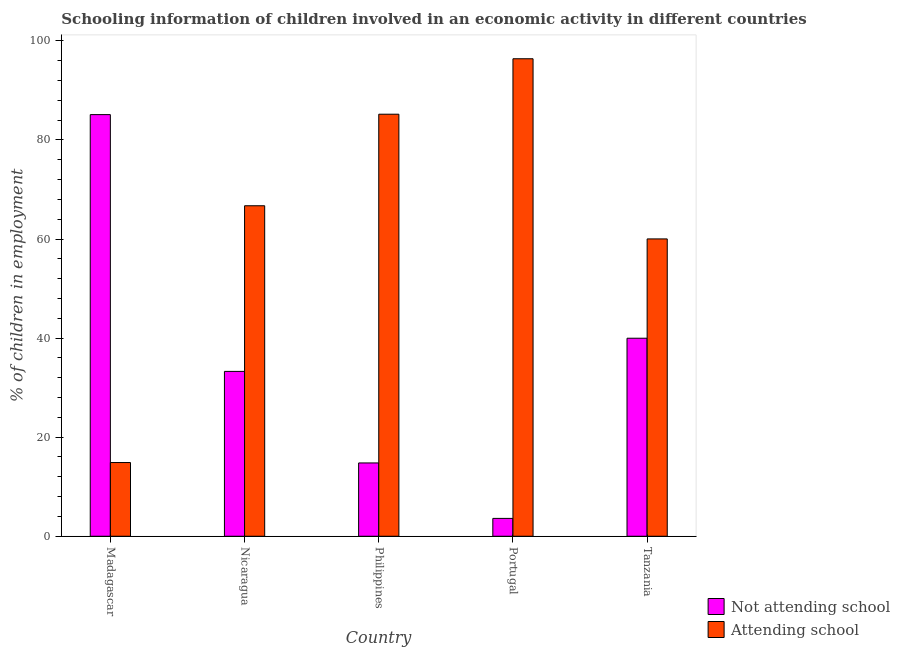How many groups of bars are there?
Your answer should be compact. 5. What is the label of the 3rd group of bars from the left?
Give a very brief answer. Philippines. What is the percentage of employed children who are attending school in Nicaragua?
Ensure brevity in your answer.  66.72. Across all countries, what is the maximum percentage of employed children who are not attending school?
Make the answer very short. 85.12. Across all countries, what is the minimum percentage of employed children who are attending school?
Your answer should be very brief. 14.88. In which country was the percentage of employed children who are not attending school maximum?
Your answer should be very brief. Madagascar. In which country was the percentage of employed children who are attending school minimum?
Provide a short and direct response. Madagascar. What is the total percentage of employed children who are attending school in the graph?
Your answer should be compact. 323.22. What is the difference between the percentage of employed children who are not attending school in Nicaragua and that in Philippines?
Keep it short and to the point. 18.48. What is the difference between the percentage of employed children who are not attending school in Philippines and the percentage of employed children who are attending school in Tanzania?
Provide a short and direct response. -45.23. What is the average percentage of employed children who are attending school per country?
Offer a very short reply. 64.64. What is the difference between the percentage of employed children who are attending school and percentage of employed children who are not attending school in Nicaragua?
Your answer should be very brief. 33.44. What is the ratio of the percentage of employed children who are not attending school in Madagascar to that in Tanzania?
Give a very brief answer. 2.13. Is the percentage of employed children who are not attending school in Madagascar less than that in Portugal?
Offer a very short reply. No. What is the difference between the highest and the second highest percentage of employed children who are not attending school?
Your answer should be compact. 45.14. What is the difference between the highest and the lowest percentage of employed children who are not attending school?
Provide a short and direct response. 81.51. In how many countries, is the percentage of employed children who are not attending school greater than the average percentage of employed children who are not attending school taken over all countries?
Give a very brief answer. 2. What does the 1st bar from the left in Nicaragua represents?
Offer a terse response. Not attending school. What does the 2nd bar from the right in Nicaragua represents?
Provide a succinct answer. Not attending school. Are all the bars in the graph horizontal?
Give a very brief answer. No. What is the difference between two consecutive major ticks on the Y-axis?
Offer a very short reply. 20. Does the graph contain any zero values?
Make the answer very short. No. How are the legend labels stacked?
Your response must be concise. Vertical. What is the title of the graph?
Offer a very short reply. Schooling information of children involved in an economic activity in different countries. Does "Excluding technical cooperation" appear as one of the legend labels in the graph?
Give a very brief answer. No. What is the label or title of the Y-axis?
Keep it short and to the point. % of children in employment. What is the % of children in employment in Not attending school in Madagascar?
Ensure brevity in your answer.  85.12. What is the % of children in employment of Attending school in Madagascar?
Give a very brief answer. 14.88. What is the % of children in employment of Not attending school in Nicaragua?
Your answer should be very brief. 33.28. What is the % of children in employment in Attending school in Nicaragua?
Keep it short and to the point. 66.72. What is the % of children in employment in Not attending school in Philippines?
Offer a terse response. 14.8. What is the % of children in employment in Attending school in Philippines?
Provide a short and direct response. 85.2. What is the % of children in employment of Not attending school in Portugal?
Make the answer very short. 3.6. What is the % of children in employment of Attending school in Portugal?
Ensure brevity in your answer.  96.4. What is the % of children in employment in Not attending school in Tanzania?
Make the answer very short. 39.98. What is the % of children in employment in Attending school in Tanzania?
Your response must be concise. 60.02. Across all countries, what is the maximum % of children in employment in Not attending school?
Make the answer very short. 85.12. Across all countries, what is the maximum % of children in employment of Attending school?
Your answer should be compact. 96.4. Across all countries, what is the minimum % of children in employment of Not attending school?
Ensure brevity in your answer.  3.6. Across all countries, what is the minimum % of children in employment in Attending school?
Ensure brevity in your answer.  14.88. What is the total % of children in employment in Not attending school in the graph?
Offer a very short reply. 176.78. What is the total % of children in employment in Attending school in the graph?
Ensure brevity in your answer.  323.22. What is the difference between the % of children in employment in Not attending school in Madagascar and that in Nicaragua?
Ensure brevity in your answer.  51.84. What is the difference between the % of children in employment in Attending school in Madagascar and that in Nicaragua?
Give a very brief answer. -51.84. What is the difference between the % of children in employment in Not attending school in Madagascar and that in Philippines?
Ensure brevity in your answer.  70.32. What is the difference between the % of children in employment of Attending school in Madagascar and that in Philippines?
Make the answer very short. -70.32. What is the difference between the % of children in employment of Not attending school in Madagascar and that in Portugal?
Offer a terse response. 81.51. What is the difference between the % of children in employment in Attending school in Madagascar and that in Portugal?
Keep it short and to the point. -81.51. What is the difference between the % of children in employment of Not attending school in Madagascar and that in Tanzania?
Your response must be concise. 45.14. What is the difference between the % of children in employment in Attending school in Madagascar and that in Tanzania?
Offer a terse response. -45.14. What is the difference between the % of children in employment of Not attending school in Nicaragua and that in Philippines?
Provide a succinct answer. 18.48. What is the difference between the % of children in employment in Attending school in Nicaragua and that in Philippines?
Make the answer very short. -18.48. What is the difference between the % of children in employment in Not attending school in Nicaragua and that in Portugal?
Your answer should be compact. 29.68. What is the difference between the % of children in employment of Attending school in Nicaragua and that in Portugal?
Provide a succinct answer. -29.68. What is the difference between the % of children in employment of Not attending school in Nicaragua and that in Tanzania?
Make the answer very short. -6.69. What is the difference between the % of children in employment of Attending school in Nicaragua and that in Tanzania?
Make the answer very short. 6.69. What is the difference between the % of children in employment of Not attending school in Philippines and that in Portugal?
Give a very brief answer. 11.19. What is the difference between the % of children in employment of Attending school in Philippines and that in Portugal?
Keep it short and to the point. -11.19. What is the difference between the % of children in employment of Not attending school in Philippines and that in Tanzania?
Ensure brevity in your answer.  -25.18. What is the difference between the % of children in employment in Attending school in Philippines and that in Tanzania?
Your response must be concise. 25.18. What is the difference between the % of children in employment of Not attending school in Portugal and that in Tanzania?
Provide a short and direct response. -36.37. What is the difference between the % of children in employment of Attending school in Portugal and that in Tanzania?
Offer a terse response. 36.37. What is the difference between the % of children in employment of Not attending school in Madagascar and the % of children in employment of Attending school in Nicaragua?
Provide a short and direct response. 18.4. What is the difference between the % of children in employment in Not attending school in Madagascar and the % of children in employment in Attending school in Philippines?
Your response must be concise. -0.08. What is the difference between the % of children in employment in Not attending school in Madagascar and the % of children in employment in Attending school in Portugal?
Provide a succinct answer. -11.28. What is the difference between the % of children in employment of Not attending school in Madagascar and the % of children in employment of Attending school in Tanzania?
Ensure brevity in your answer.  25.09. What is the difference between the % of children in employment of Not attending school in Nicaragua and the % of children in employment of Attending school in Philippines?
Your answer should be compact. -51.92. What is the difference between the % of children in employment in Not attending school in Nicaragua and the % of children in employment in Attending school in Portugal?
Offer a very short reply. -63.11. What is the difference between the % of children in employment of Not attending school in Nicaragua and the % of children in employment of Attending school in Tanzania?
Your answer should be compact. -26.74. What is the difference between the % of children in employment in Not attending school in Philippines and the % of children in employment in Attending school in Portugal?
Ensure brevity in your answer.  -81.6. What is the difference between the % of children in employment in Not attending school in Philippines and the % of children in employment in Attending school in Tanzania?
Keep it short and to the point. -45.23. What is the difference between the % of children in employment in Not attending school in Portugal and the % of children in employment in Attending school in Tanzania?
Ensure brevity in your answer.  -56.42. What is the average % of children in employment of Not attending school per country?
Provide a succinct answer. 35.36. What is the average % of children in employment in Attending school per country?
Offer a very short reply. 64.64. What is the difference between the % of children in employment of Not attending school and % of children in employment of Attending school in Madagascar?
Keep it short and to the point. 70.24. What is the difference between the % of children in employment in Not attending school and % of children in employment in Attending school in Nicaragua?
Offer a terse response. -33.44. What is the difference between the % of children in employment of Not attending school and % of children in employment of Attending school in Philippines?
Your answer should be compact. -70.4. What is the difference between the % of children in employment in Not attending school and % of children in employment in Attending school in Portugal?
Keep it short and to the point. -92.79. What is the difference between the % of children in employment of Not attending school and % of children in employment of Attending school in Tanzania?
Ensure brevity in your answer.  -20.05. What is the ratio of the % of children in employment of Not attending school in Madagascar to that in Nicaragua?
Your answer should be compact. 2.56. What is the ratio of the % of children in employment of Attending school in Madagascar to that in Nicaragua?
Provide a succinct answer. 0.22. What is the ratio of the % of children in employment of Not attending school in Madagascar to that in Philippines?
Make the answer very short. 5.75. What is the ratio of the % of children in employment of Attending school in Madagascar to that in Philippines?
Offer a terse response. 0.17. What is the ratio of the % of children in employment in Not attending school in Madagascar to that in Portugal?
Ensure brevity in your answer.  23.61. What is the ratio of the % of children in employment of Attending school in Madagascar to that in Portugal?
Your answer should be very brief. 0.15. What is the ratio of the % of children in employment in Not attending school in Madagascar to that in Tanzania?
Keep it short and to the point. 2.13. What is the ratio of the % of children in employment of Attending school in Madagascar to that in Tanzania?
Provide a succinct answer. 0.25. What is the ratio of the % of children in employment in Not attending school in Nicaragua to that in Philippines?
Offer a terse response. 2.25. What is the ratio of the % of children in employment in Attending school in Nicaragua to that in Philippines?
Your answer should be very brief. 0.78. What is the ratio of the % of children in employment in Not attending school in Nicaragua to that in Portugal?
Keep it short and to the point. 9.23. What is the ratio of the % of children in employment of Attending school in Nicaragua to that in Portugal?
Make the answer very short. 0.69. What is the ratio of the % of children in employment of Not attending school in Nicaragua to that in Tanzania?
Your answer should be very brief. 0.83. What is the ratio of the % of children in employment of Attending school in Nicaragua to that in Tanzania?
Give a very brief answer. 1.11. What is the ratio of the % of children in employment of Not attending school in Philippines to that in Portugal?
Offer a terse response. 4.11. What is the ratio of the % of children in employment in Attending school in Philippines to that in Portugal?
Make the answer very short. 0.88. What is the ratio of the % of children in employment in Not attending school in Philippines to that in Tanzania?
Your answer should be very brief. 0.37. What is the ratio of the % of children in employment of Attending school in Philippines to that in Tanzania?
Offer a terse response. 1.42. What is the ratio of the % of children in employment of Not attending school in Portugal to that in Tanzania?
Keep it short and to the point. 0.09. What is the ratio of the % of children in employment of Attending school in Portugal to that in Tanzania?
Your answer should be very brief. 1.61. What is the difference between the highest and the second highest % of children in employment of Not attending school?
Provide a short and direct response. 45.14. What is the difference between the highest and the second highest % of children in employment in Attending school?
Give a very brief answer. 11.19. What is the difference between the highest and the lowest % of children in employment of Not attending school?
Your answer should be very brief. 81.51. What is the difference between the highest and the lowest % of children in employment of Attending school?
Your answer should be compact. 81.51. 